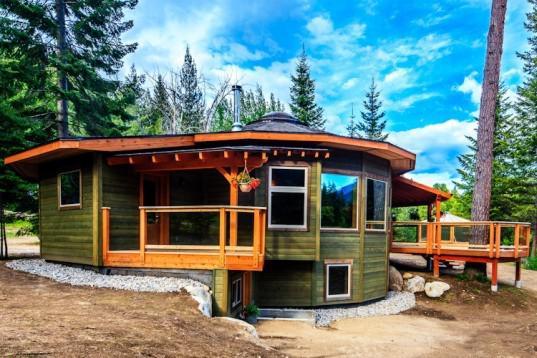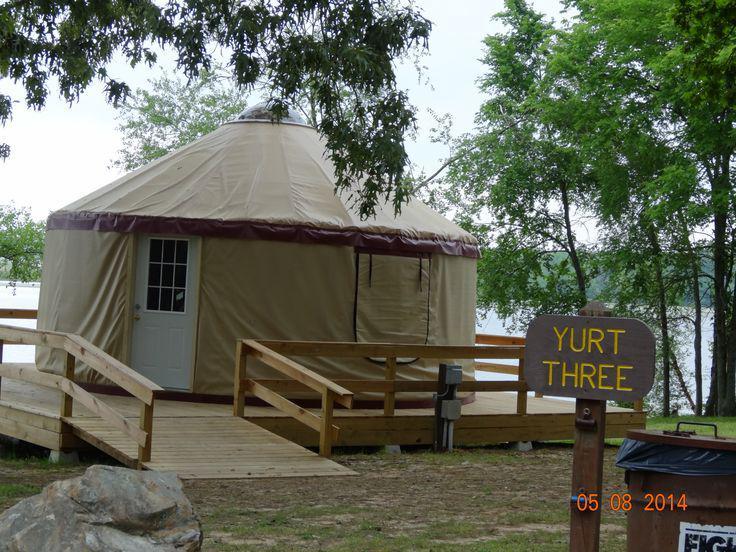The first image is the image on the left, the second image is the image on the right. For the images displayed, is the sentence "One image shows a yurt standing on a fresh-water shore, and the other image shows a yurt with decks extending from it and evergreens behind it." factually correct? Answer yes or no. Yes. The first image is the image on the left, the second image is the image on the right. Given the left and right images, does the statement "A yurt in one image features a white door with nine-pane window and a wooden walkway, but has no visible windows." hold true? Answer yes or no. Yes. 